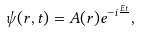Convert formula to latex. <formula><loc_0><loc_0><loc_500><loc_500>\psi ( { r } , t ) = A ( { r } ) e ^ { - i \frac { E t } { } } ,</formula> 